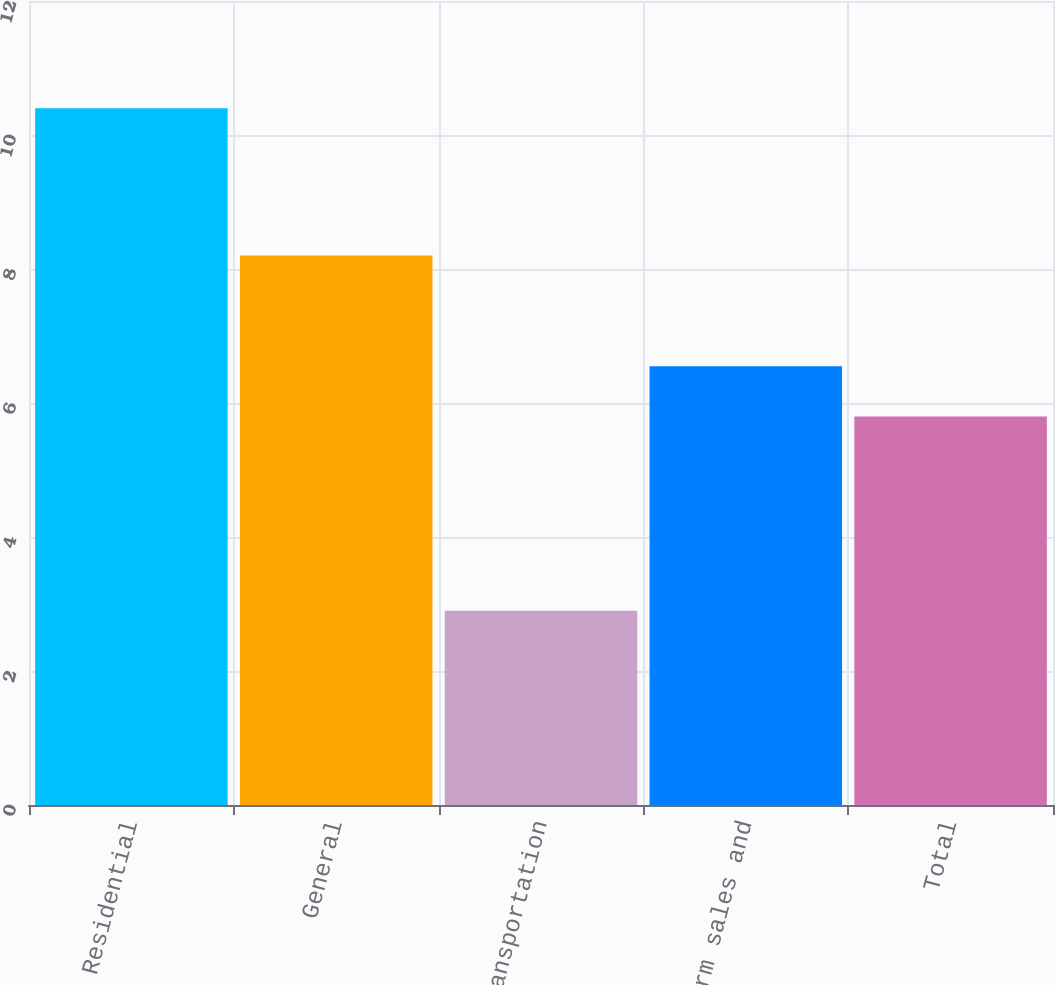<chart> <loc_0><loc_0><loc_500><loc_500><bar_chart><fcel>Residential<fcel>General<fcel>Firm transportation<fcel>Total firm sales and<fcel>Total<nl><fcel>10.4<fcel>8.2<fcel>2.9<fcel>6.55<fcel>5.8<nl></chart> 